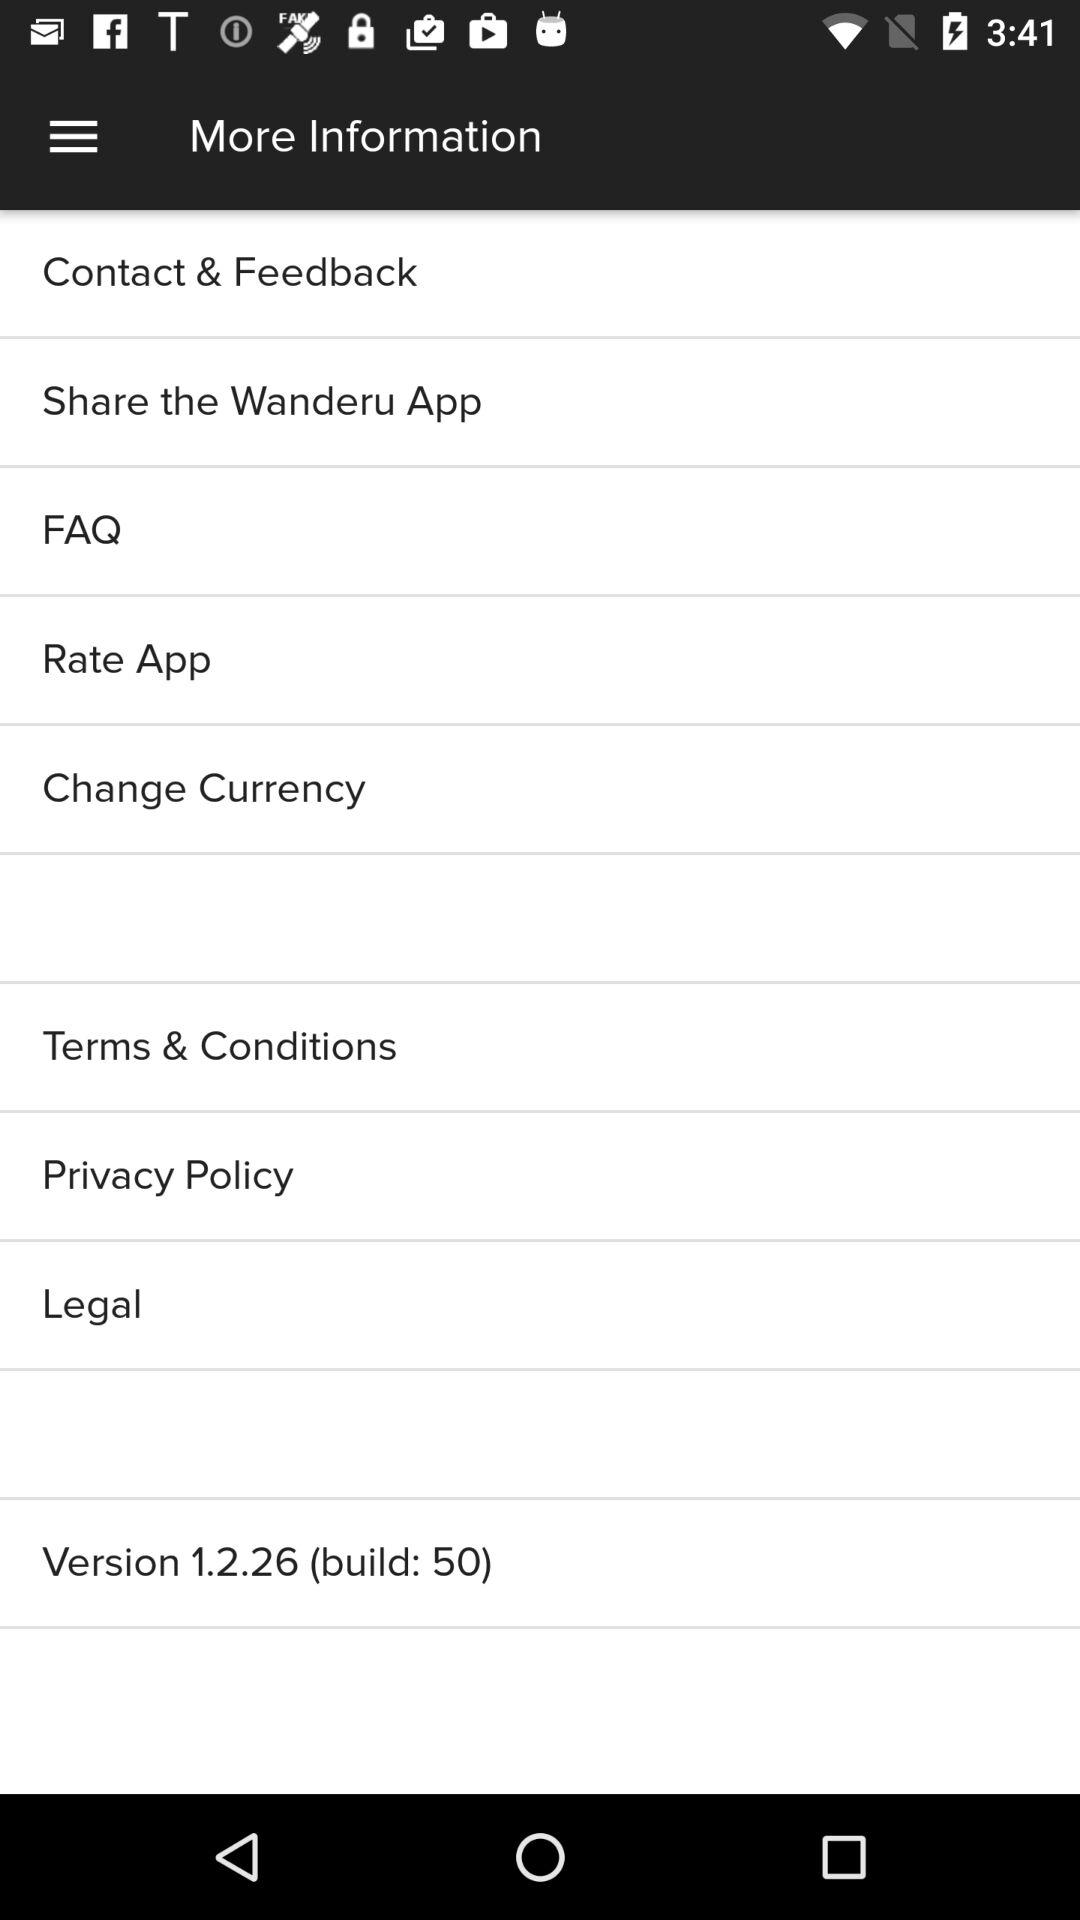What is the version? The version is 1.2.26 (build: 50). 